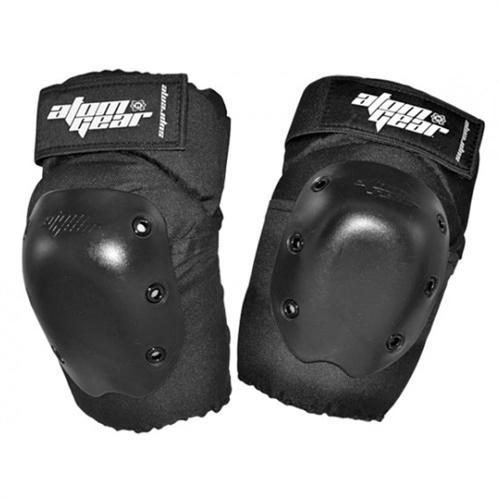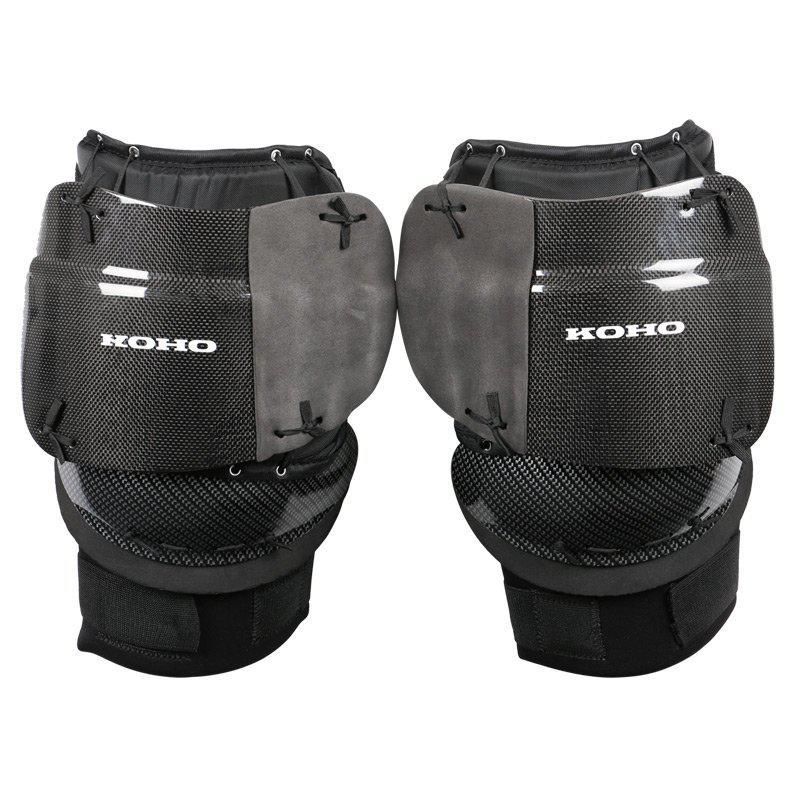The first image is the image on the left, the second image is the image on the right. Considering the images on both sides, is "Left image features one pair of all-black knee pads with three eyelet rivets per side." valid? Answer yes or no. Yes. The first image is the image on the left, the second image is the image on the right. Considering the images on both sides, is "There are exactly two velcro closures in the image on the left." valid? Answer yes or no. Yes. 